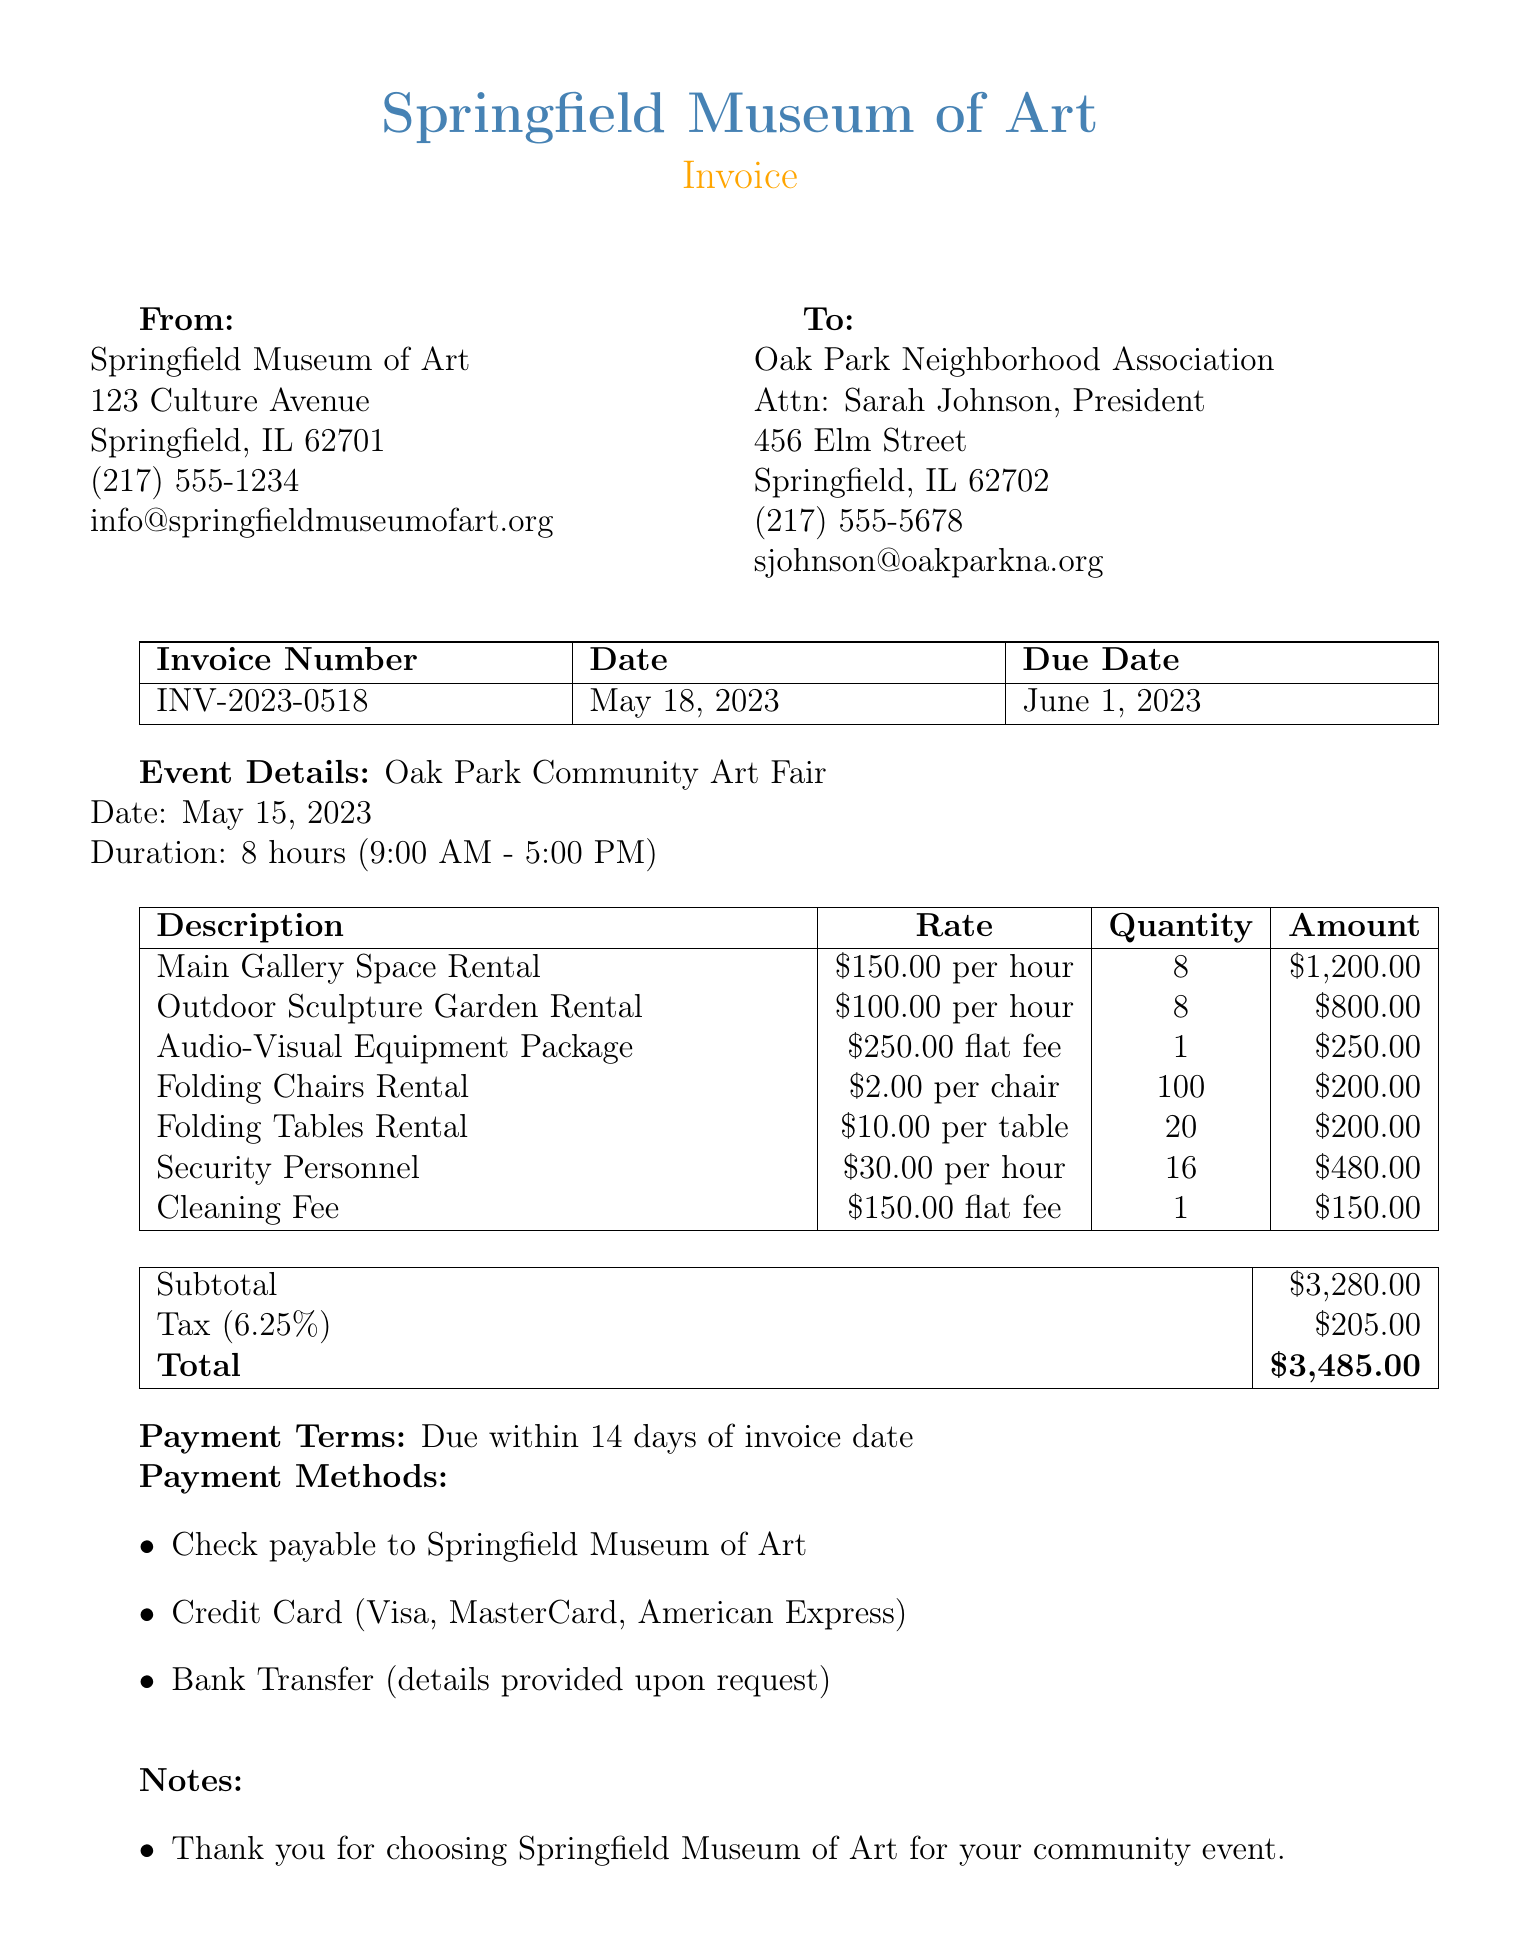What is the invoice number? The invoice number is stated prominently in the document for reference.
Answer: INV-2023-0518 What is the due date for payment? The due date is specified in the document and indicates when the payment is expected.
Answer: June 1, 2023 How many hours was the main gallery space rented? The document mentions the duration of the rental for the specific space.
Answer: 8 hours What is the rate for the outdoor sculpture garden rental? The rate for renting the outdoor sculpture garden is detailed in the line items of the invoice.
Answer: $100.00 per hour How much was charged for folding chairs rental? The total amount for the folding chairs rental is calculated and listed in the line items.
Answer: $200.00 What is the subtotal before tax? The subtotal represents the total amount before any tax is applied, and it's listed clearly.
Answer: $3,280.00 How much is the tax rate applied? The tax rate is explicitly stated in the document contributing to the total amount owed.
Answer: 6.25% What is the total amount due? The total amount combines the subtotal and tax, providing the complete charge.
Answer: $3,485.00 Who should be contacted for questions about the event? The document provides contact information for inquiries related to the event coordination.
Answer: Emily Chen 